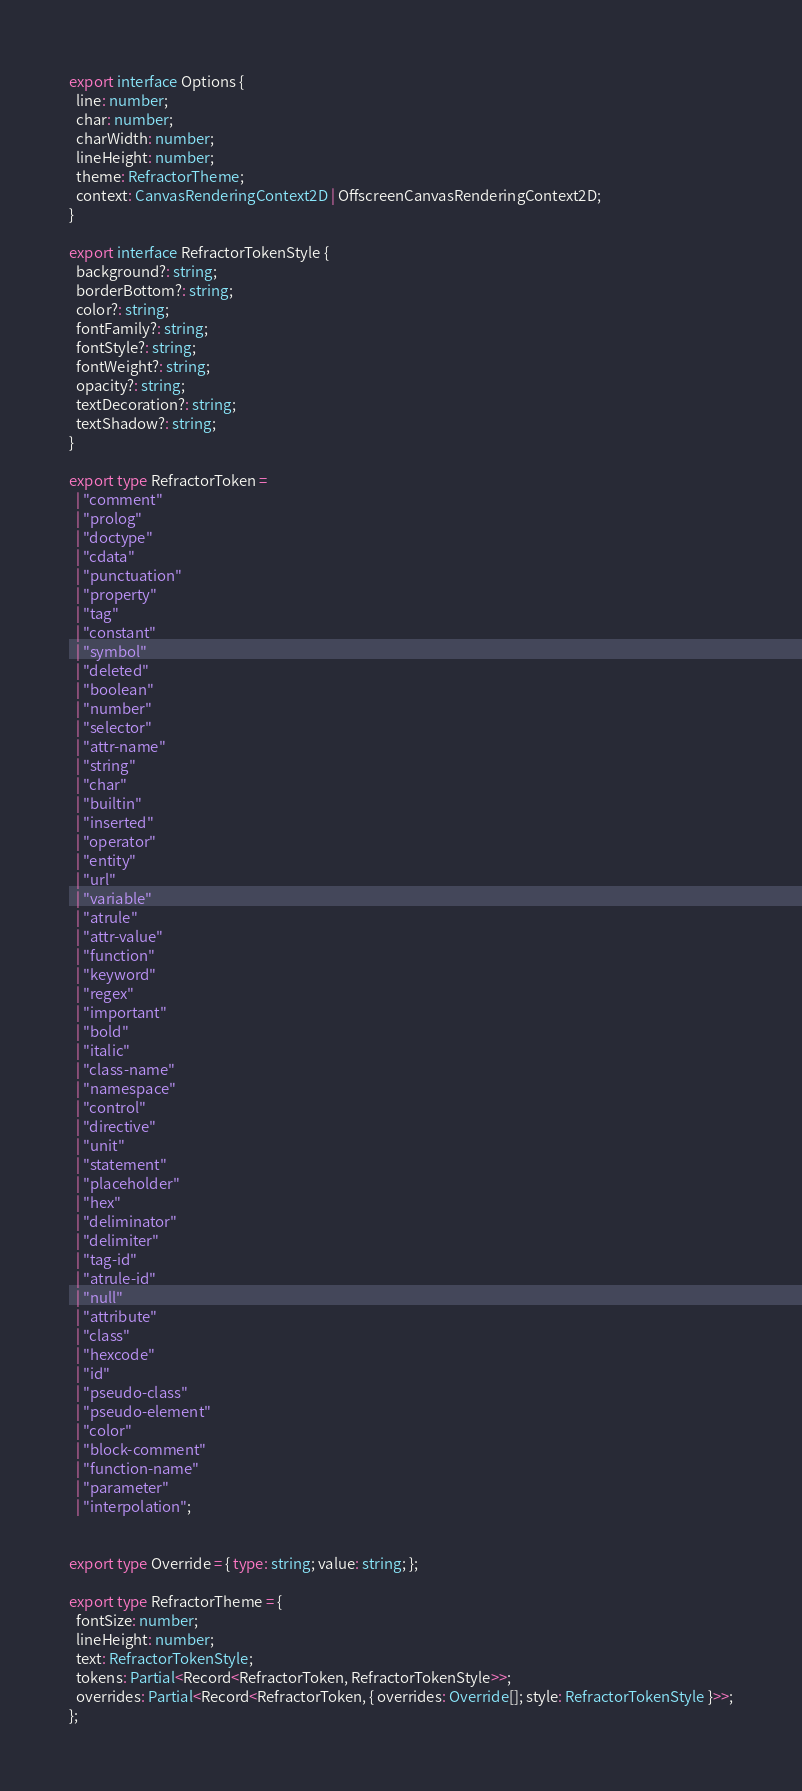<code> <loc_0><loc_0><loc_500><loc_500><_TypeScript_>export interface Options {
  line: number;
  char: number;
  charWidth: number;
  lineHeight: number;
  theme: RefractorTheme;
  context: CanvasRenderingContext2D | OffscreenCanvasRenderingContext2D;
}

export interface RefractorTokenStyle {
  background?: string;
  borderBottom?: string;
  color?: string;
  fontFamily?: string;
  fontStyle?: string;
  fontWeight?: string;
  opacity?: string;
  textDecoration?: string;
  textShadow?: string;
}

export type RefractorToken =
  | "comment"
  | "prolog"
  | "doctype"
  | "cdata"
  | "punctuation"
  | "property"
  | "tag"
  | "constant"
  | "symbol"
  | "deleted"
  | "boolean"
  | "number"
  | "selector"
  | "attr-name"
  | "string"
  | "char"
  | "builtin"
  | "inserted"
  | "operator"
  | "entity"
  | "url"
  | "variable"
  | "atrule"
  | "attr-value"
  | "function"
  | "keyword"
  | "regex"
  | "important"
  | "bold"
  | "italic"
  | "class-name"
  | "namespace"
  | "control"
  | "directive"
  | "unit"
  | "statement"
  | "placeholder"
  | "hex"
  | "deliminator"
  | "delimiter"
  | "tag-id"
  | "atrule-id"
  | "null"
  | "attribute"
  | "class"
  | "hexcode"
  | "id"
  | "pseudo-class"
  | "pseudo-element"
  | "color"
  | "block-comment"
  | "function-name"
  | "parameter"
  | "interpolation";


export type Override = { type: string; value: string; };

export type RefractorTheme = {
  fontSize: number;
  lineHeight: number;
  text: RefractorTokenStyle;
  tokens: Partial<Record<RefractorToken, RefractorTokenStyle>>;
  overrides: Partial<Record<RefractorToken, { overrides: Override[]; style: RefractorTokenStyle }>>;
};
</code> 